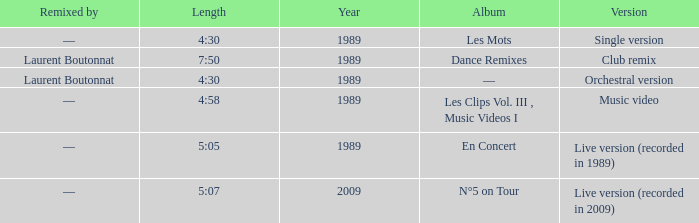Album of les mots had what lowest year? 1989.0. 